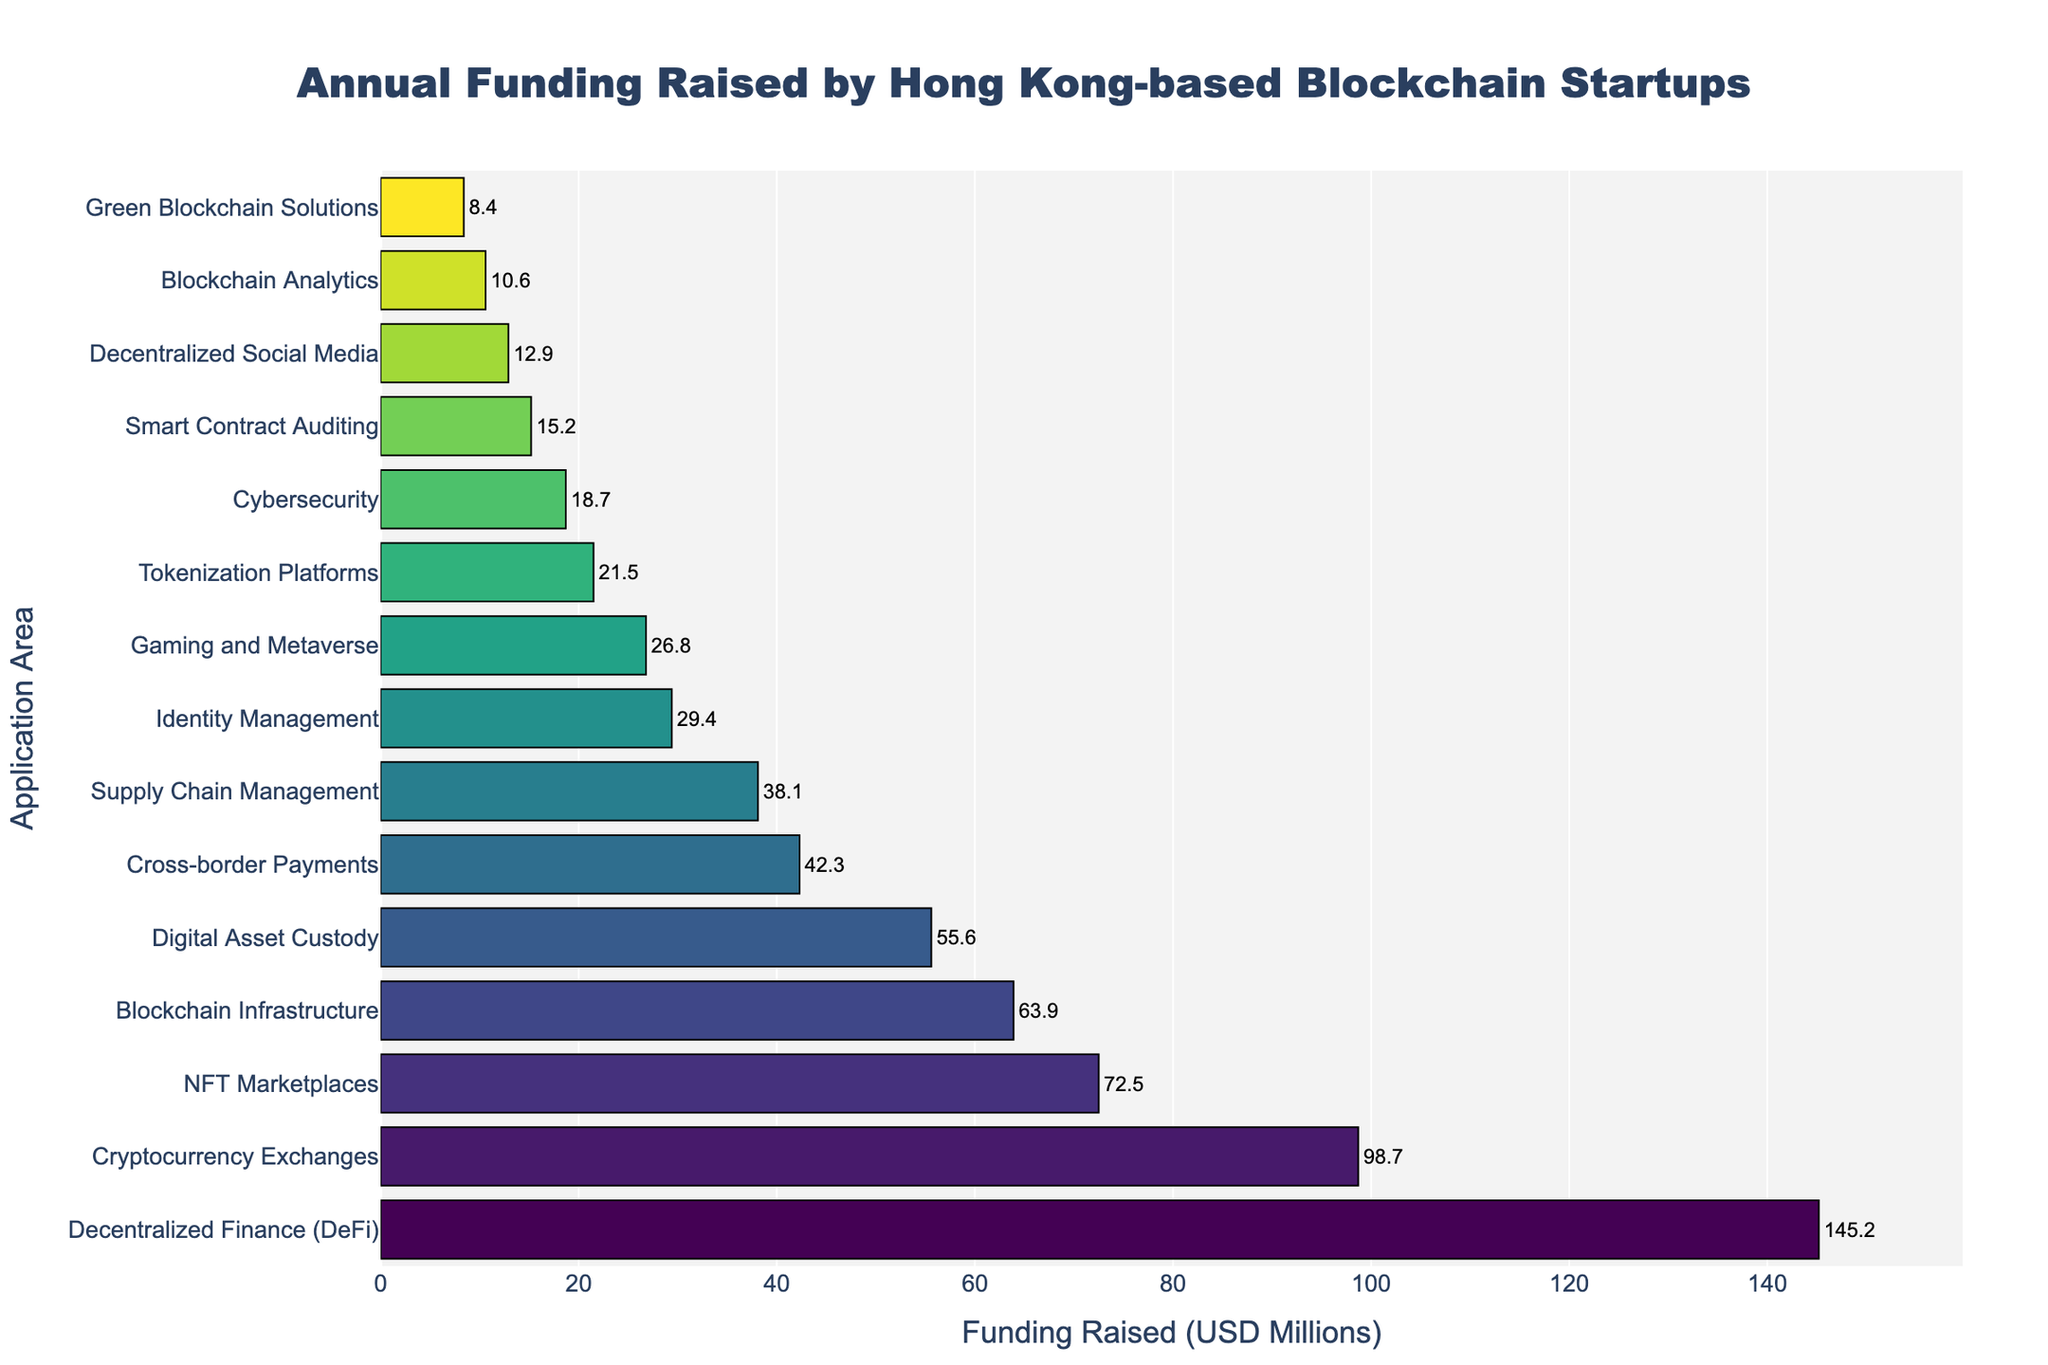What is the application area that raised the most funding? The bar chart indicates that "Decentralized Finance (DeFi)" has the longest bar, representing the highest funding raised among all application areas.
Answer: Decentralized Finance (DeFi) Which application area raised more funding: NFT Marketplaces or Cryptocurrency Exchanges? By looking at the lengths of the bars, "Cryptocurrency Exchanges" raised $98.7 million, which is longer than "NFT Marketplaces" that raised $72.5 million.
Answer: Cryptocurrency Exchanges What is the combined funding raised by Digital Asset Custody and Cross-border Payments? From the chart, "Digital Asset Custody" raised $55.6 million, and "Cross-border Payments" raised $42.3 million. Summing these, $55.6 million + $42.3 million = $97.9 million.
Answer: $97.9 million Which application area raised the least amount of funding? The shortest bar on the chart corresponds to "Green Blockchain Solutions", indicating it raised the least funding.
Answer: Green Blockchain Solutions How much more funding did Blockchain Infrastructure raise compared to Supply Chain Management? "Blockchain Infrastructure" raised $63.9 million, while "Supply Chain Management" raised $38.1 million. The difference is $63.9 million - $38.1 million = $25.8 million.
Answer: $25.8 million List the application areas that raised over $50 million in funding. The chart shows that "Decentralized Finance (DeFi)", "Cryptocurrency Exchanges", "NFT Marketplaces", "Blockchain Infrastructure", and "Digital Asset Custody" have bars extending beyond the $50 million mark.
Answer: Decentralized Finance (DeFi), Cryptocurrency Exchanges, NFT Marketplaces, Blockchain Infrastructure, Digital Asset Custody Which application area raised the closest amount of funding to Identity Management? "Identity Management" raised $29.4 million. The bar right next and slightly less to it is "Gaming and Metaverse" with $26.8 million, making it the closest.
Answer: Gaming and Metaverse How much is the total funding raised by the top three application areas? From the chart, the top three areas are "Decentralized Finance (DeFi)" with $145.2 million, "Cryptocurrency Exchanges" with $98.7 million, and "NFT Marketplaces" with $72.5 million. Adding them up: $145.2 million + $98.7 million + $72.5 million = $316.4 million.
Answer: $316.4 million 